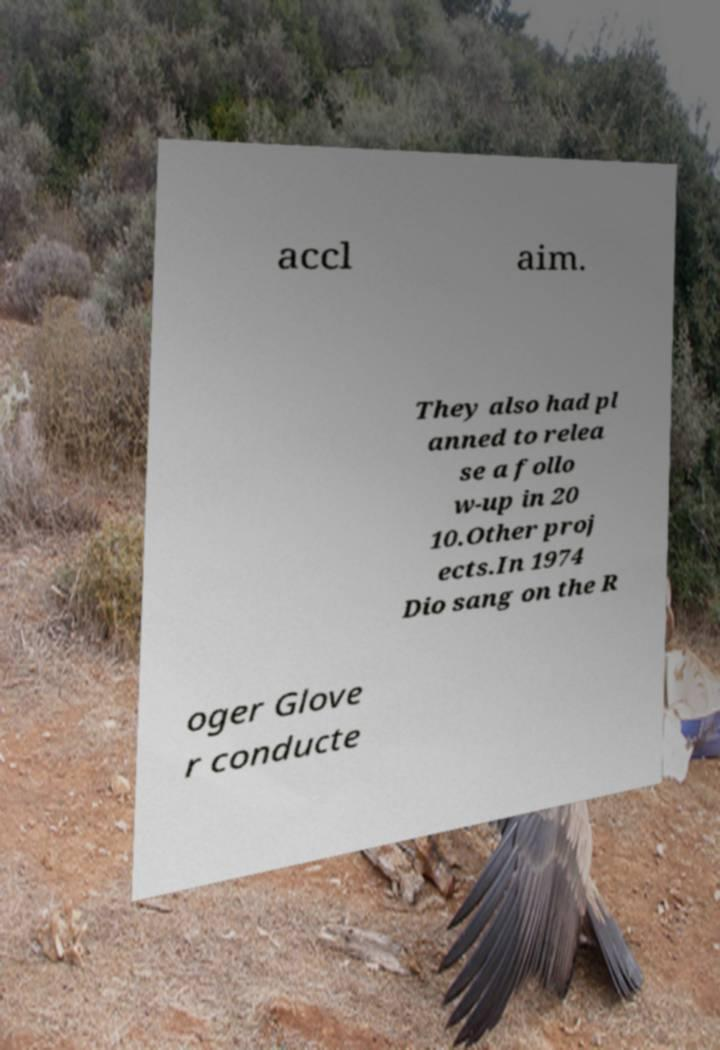Please identify and transcribe the text found in this image. accl aim. They also had pl anned to relea se a follo w-up in 20 10.Other proj ects.In 1974 Dio sang on the R oger Glove r conducte 